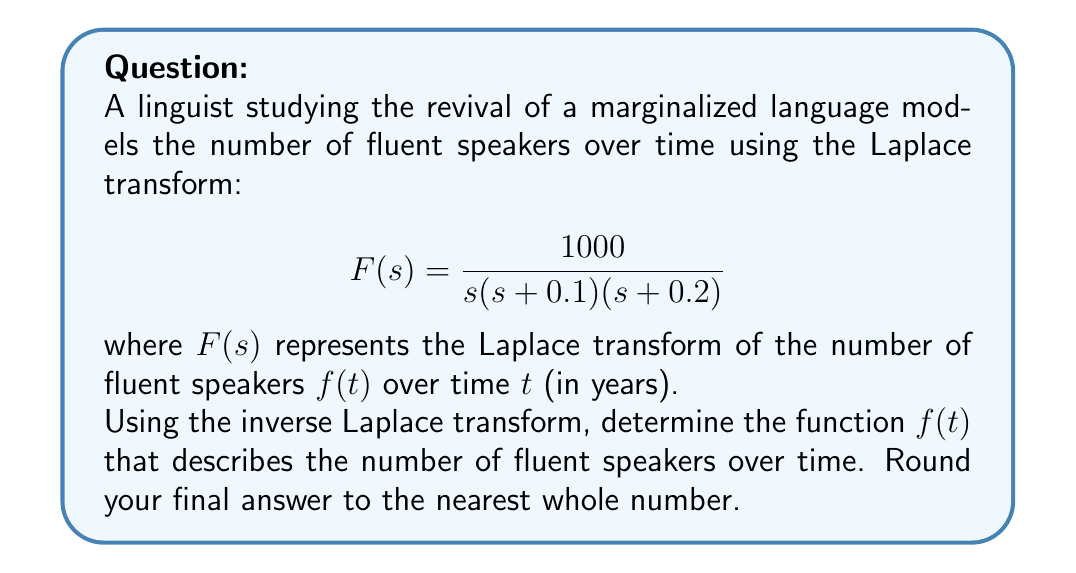Can you answer this question? To solve this problem, we need to apply the inverse Laplace transform to $F(s)$. Let's break it down step-by-step:

1) First, we need to decompose $F(s)$ into partial fractions:

   $$F(s) = \frac{1000}{s(s+0.1)(s+0.2)} = \frac{A}{s} + \frac{B}{s+0.1} + \frac{C}{s+0.2}$$

2) To find A, B, and C, we multiply both sides by $s(s+0.1)(s+0.2)$:

   $$1000 = A(s+0.1)(s+0.2) + Bs(s+0.2) + Cs(s+0.1)$$

3) Substituting $s=0$, $s=-0.1$, and $s=-0.2$ respectively:

   For $s=0$: $1000 = 0.02A$, so $A = 50000$
   For $s=-0.1$: $1000 = 0.01B$, so $B = 100000$
   For $s=-0.2$: $1000 = -0.02C$, so $C = -50000$

4) Now we have:

   $$F(s) = \frac{50000}{s} + \frac{100000}{s+0.1} - \frac{50000}{s+0.2}$$

5) Using the inverse Laplace transform properties:

   $\mathcal{L}^{-1}\{\frac{1}{s}\} = 1$
   $\mathcal{L}^{-1}\{\frac{1}{s+a}\} = e^{-at}$

6) Applying the inverse Laplace transform:

   $$f(t) = 50000 + 100000e^{-0.1t} - 50000e^{-0.2t}$$

7) Rounding to the nearest whole number:

   $$f(t) \approx 50000 + 100000e^{-0.1t} - 50000e^{-0.2t}$$
Answer: $f(t) \approx 50000 + 100000e^{-0.1t} - 50000e^{-0.2t}$ 